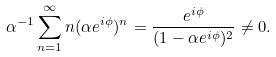Convert formula to latex. <formula><loc_0><loc_0><loc_500><loc_500>\alpha ^ { - 1 } \sum _ { n = 1 } ^ { \infty } n ( \alpha e ^ { i \phi } ) ^ { n } = \frac { e ^ { i \phi } } { ( 1 - \alpha e ^ { i \phi } ) ^ { 2 } } \neq 0 .</formula> 